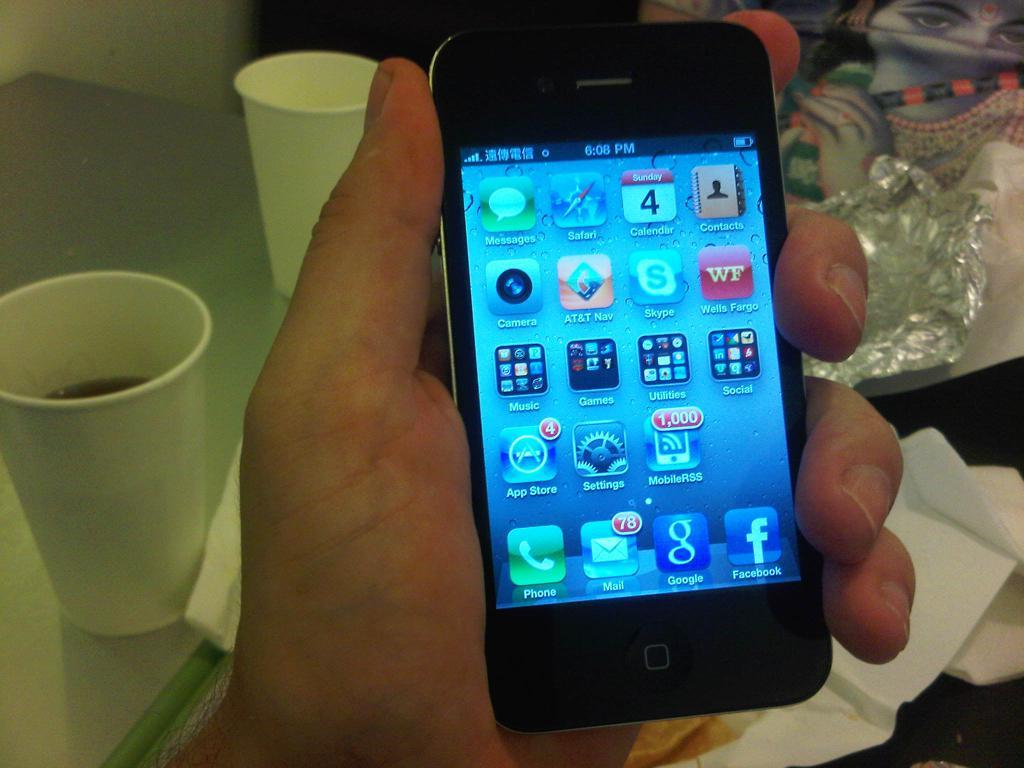<image>
Relay a brief, clear account of the picture shown. A phone has a time of 6:08 and icons for apps on it. 